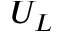Convert formula to latex. <formula><loc_0><loc_0><loc_500><loc_500>U _ { L }</formula> 